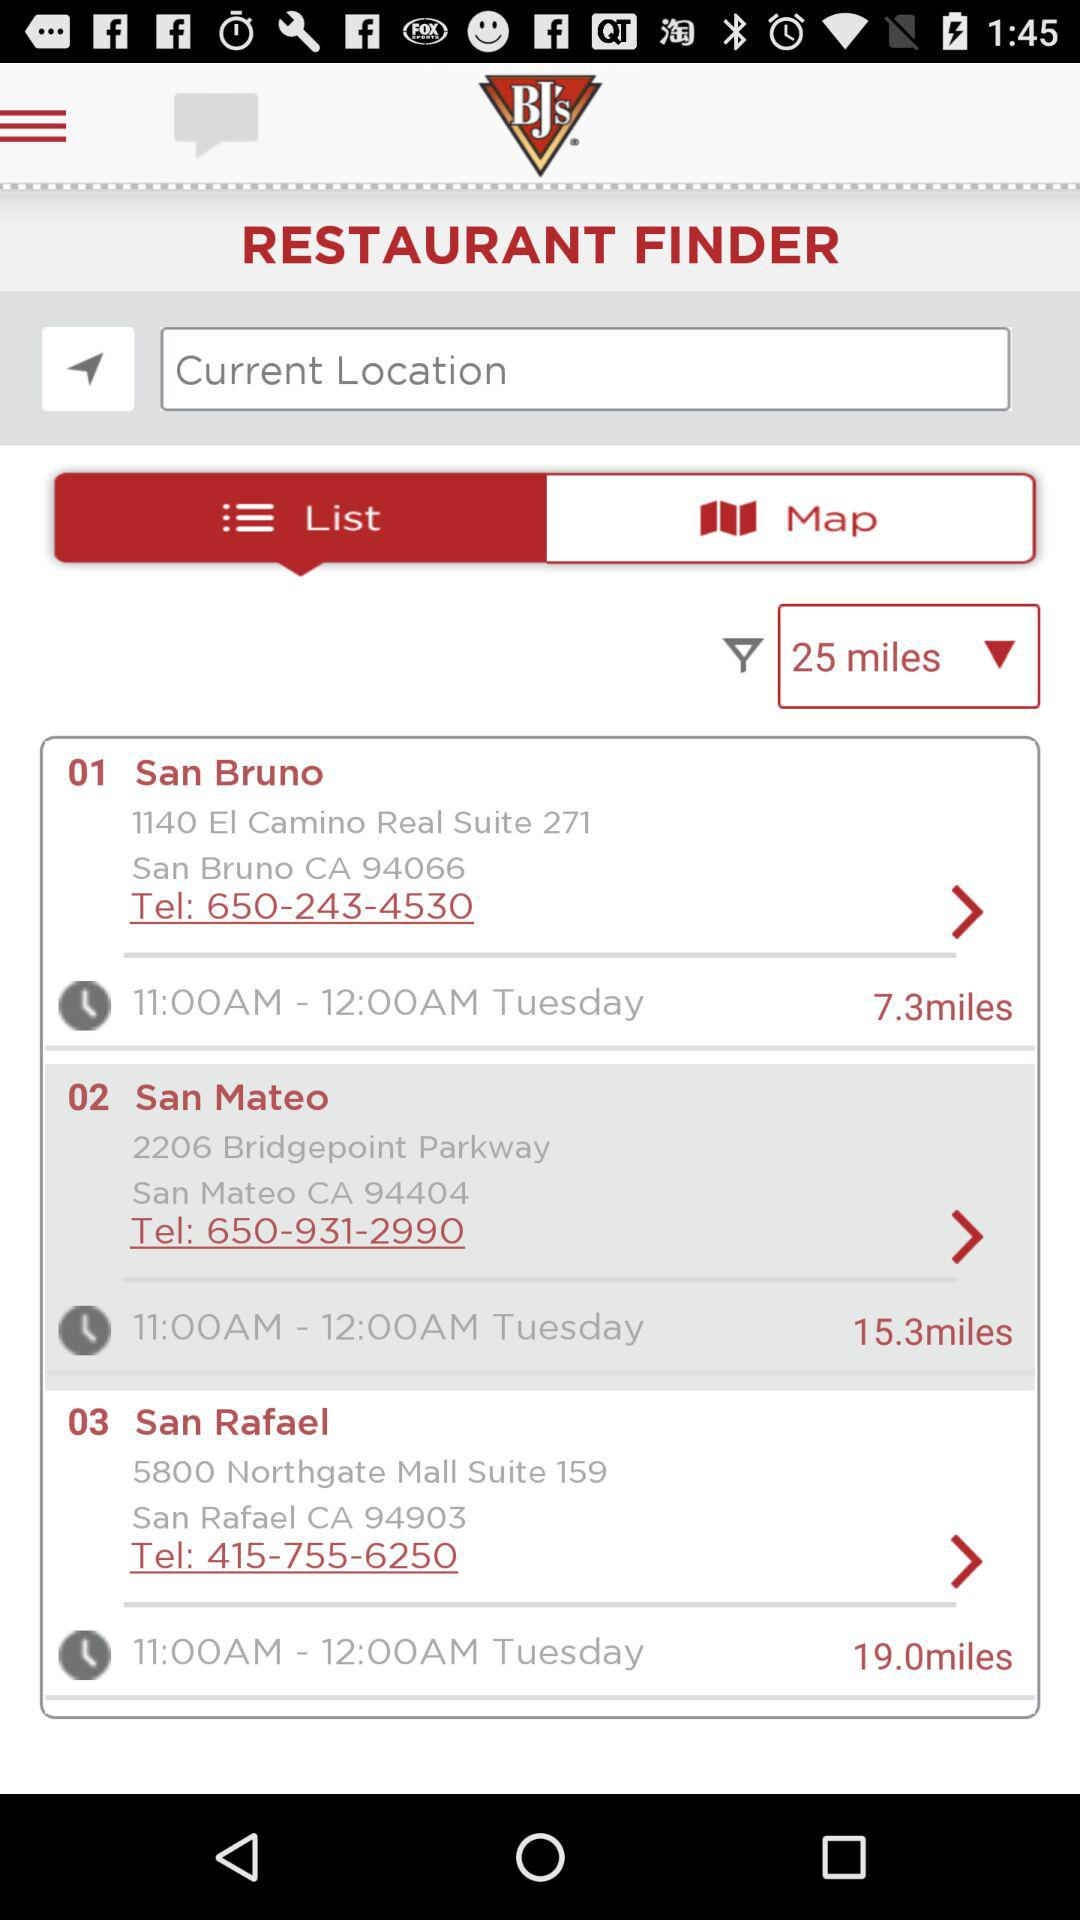What are the available restaurants? The available restaurants are "San Bruno", "San Mateo" and "San Rafael". 